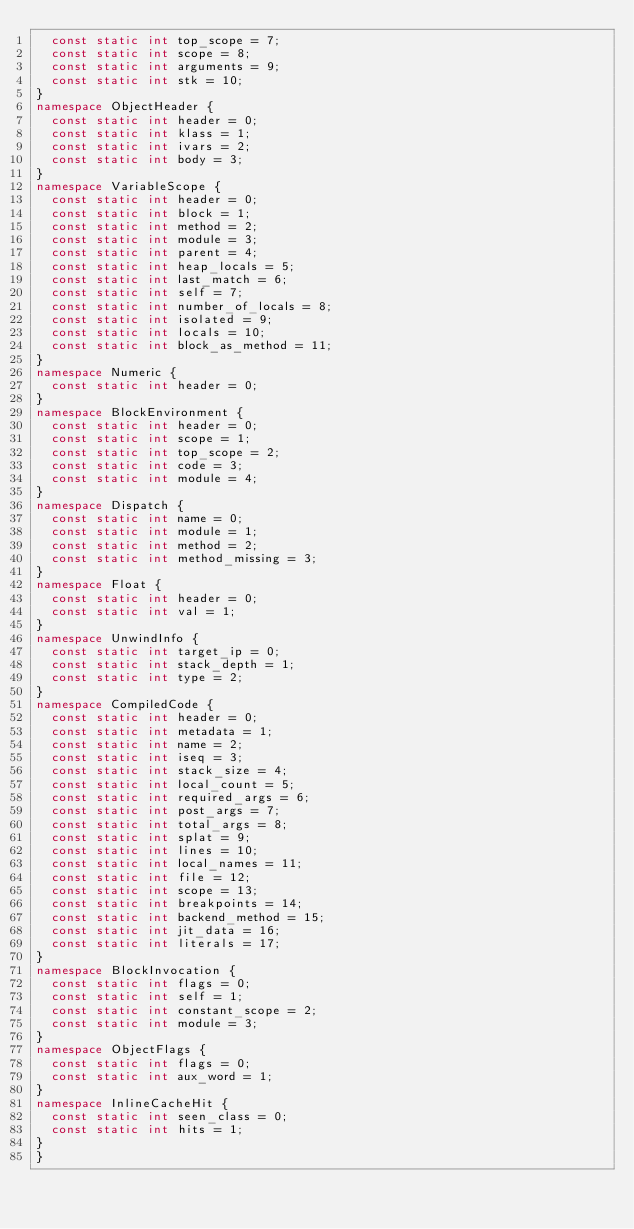<code> <loc_0><loc_0><loc_500><loc_500><_C++_>  const static int top_scope = 7;
  const static int scope = 8;
  const static int arguments = 9;
  const static int stk = 10;
}
namespace ObjectHeader {
  const static int header = 0;
  const static int klass = 1;
  const static int ivars = 2;
  const static int body = 3;
}
namespace VariableScope {
  const static int header = 0;
  const static int block = 1;
  const static int method = 2;
  const static int module = 3;
  const static int parent = 4;
  const static int heap_locals = 5;
  const static int last_match = 6;
  const static int self = 7;
  const static int number_of_locals = 8;
  const static int isolated = 9;
  const static int locals = 10;
  const static int block_as_method = 11;
}
namespace Numeric {
  const static int header = 0;
}
namespace BlockEnvironment {
  const static int header = 0;
  const static int scope = 1;
  const static int top_scope = 2;
  const static int code = 3;
  const static int module = 4;
}
namespace Dispatch {
  const static int name = 0;
  const static int module = 1;
  const static int method = 2;
  const static int method_missing = 3;
}
namespace Float {
  const static int header = 0;
  const static int val = 1;
}
namespace UnwindInfo {
  const static int target_ip = 0;
  const static int stack_depth = 1;
  const static int type = 2;
}
namespace CompiledCode {
  const static int header = 0;
  const static int metadata = 1;
  const static int name = 2;
  const static int iseq = 3;
  const static int stack_size = 4;
  const static int local_count = 5;
  const static int required_args = 6;
  const static int post_args = 7;
  const static int total_args = 8;
  const static int splat = 9;
  const static int lines = 10;
  const static int local_names = 11;
  const static int file = 12;
  const static int scope = 13;
  const static int breakpoints = 14;
  const static int backend_method = 15;
  const static int jit_data = 16;
  const static int literals = 17;
}
namespace BlockInvocation {
  const static int flags = 0;
  const static int self = 1;
  const static int constant_scope = 2;
  const static int module = 3;
}
namespace ObjectFlags {
  const static int flags = 0;
  const static int aux_word = 1;
}
namespace InlineCacheHit {
  const static int seen_class = 0;
  const static int hits = 1;
}
}
</code> 